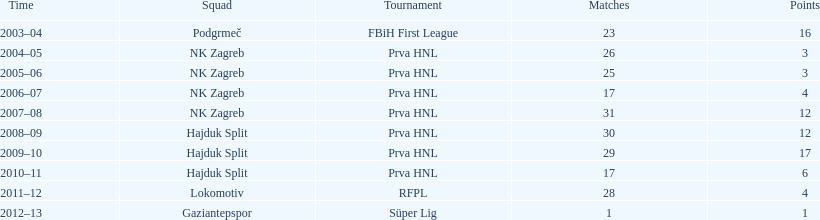What is the maximum number of goals senijad ibricic has scored in a single season? 35. 